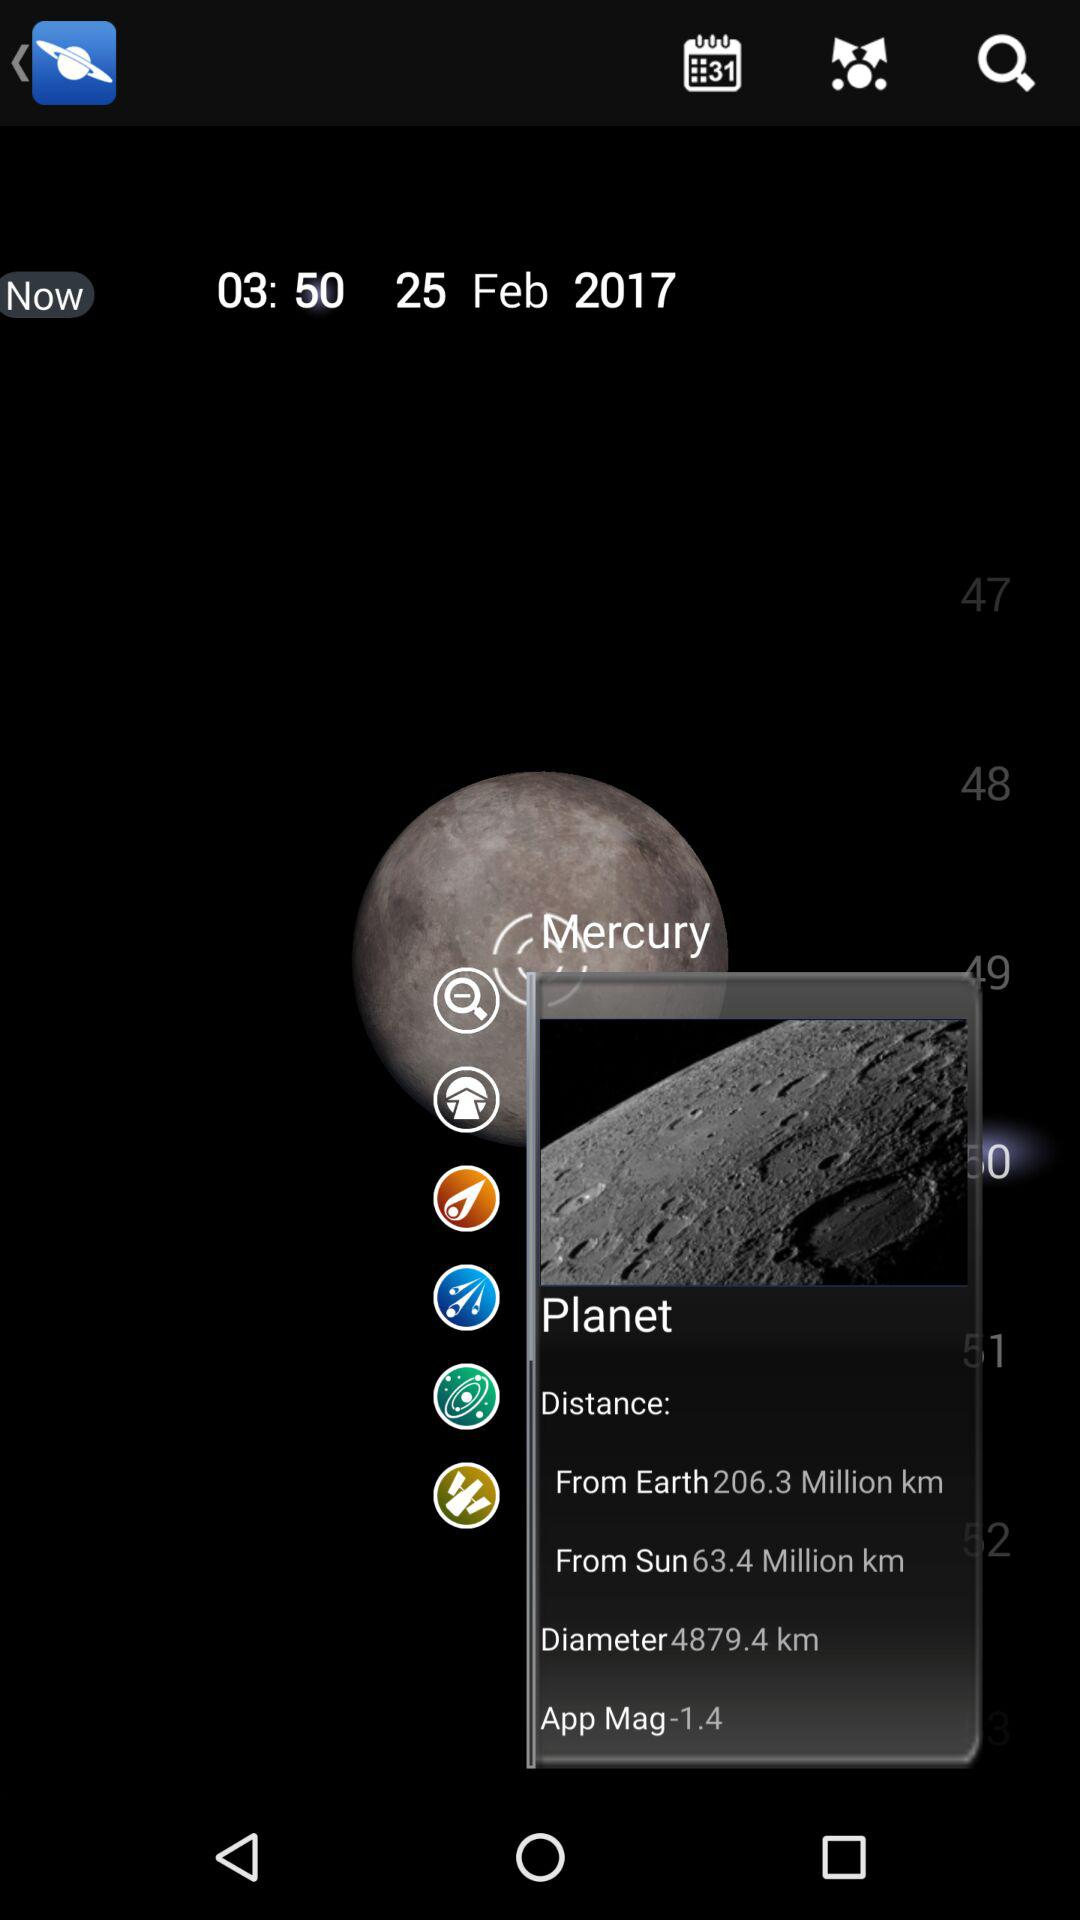What is the name of the application?
When the provided information is insufficient, respond with <no answer>. <no answer> 